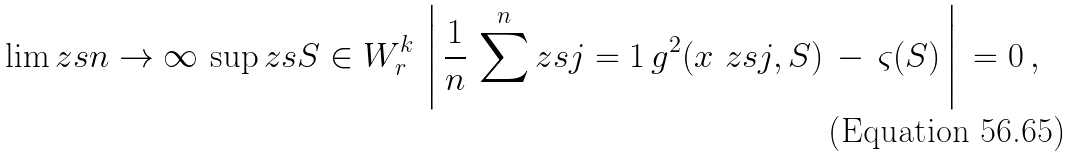<formula> <loc_0><loc_0><loc_500><loc_500>\lim _ { \ } z s { n \to \infty } \, \sup _ { \ } z s { S \in W ^ { k } _ { r } } \, \left | \, \frac { 1 } { n } \, \sum ^ { n } _ { \ } z s { j = 1 } \, g ^ { 2 } ( x _ { \ } z s { j } , S ) \, - \, \varsigma ( S ) \, \right | \, = 0 \, ,</formula> 